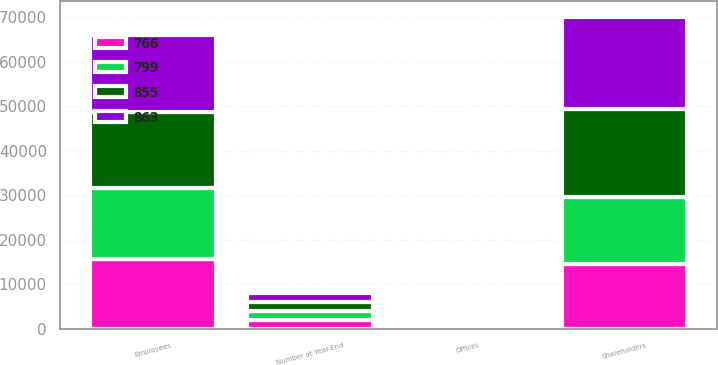<chart> <loc_0><loc_0><loc_500><loc_500><stacked_bar_chart><ecel><fcel>Number at Year-End<fcel>Shareholders<fcel>Employees<fcel>Offices<nl><fcel>855<fcel>2016<fcel>19802<fcel>16973<fcel>855<nl><fcel>863<fcel>2015<fcel>20693<fcel>17476<fcel>863<nl><fcel>766<fcel>2014<fcel>14551<fcel>15782<fcel>766<nl><fcel>799<fcel>2013<fcel>15015<fcel>15893<fcel>796<nl></chart> 